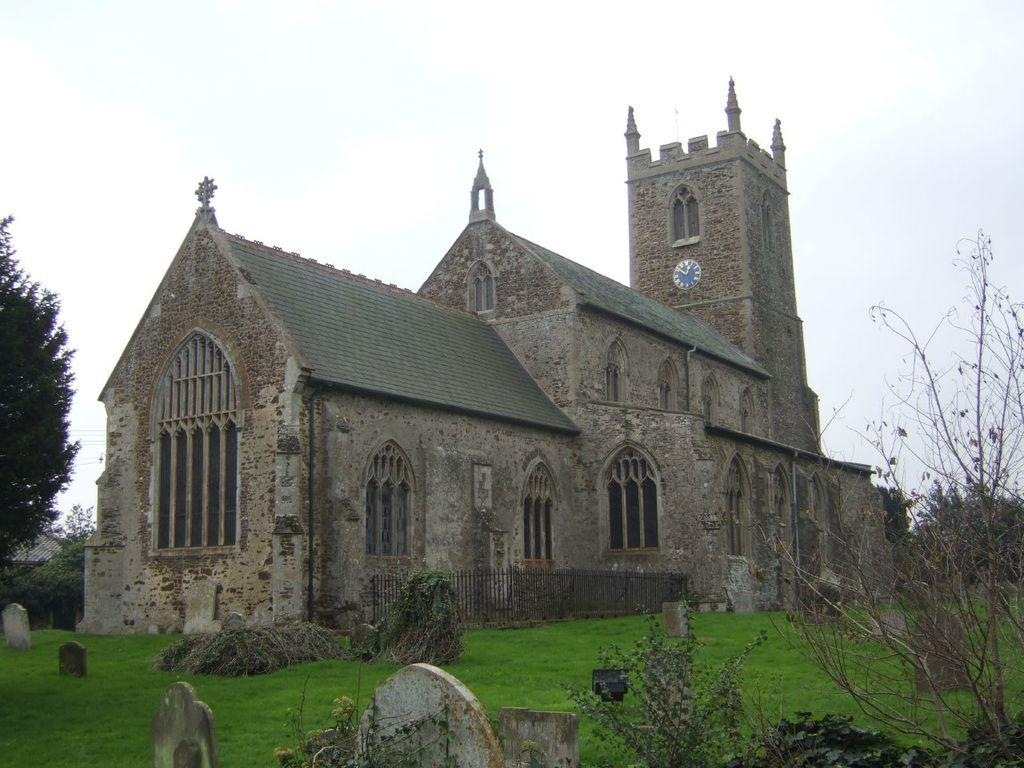What type of vegetation is present in the image? There is grass in the image. What type of structure can be seen in the image? There is a building in the image. What other natural elements are present in the image? There are trees in the image. What type of material is visible in the image? There are stones visible in the image. How many kittens are playing with the stones in the image? There are no kittens present in the image; it only features grass, a building, trees, and stones. What is the best route to take to reach the building in the image? The image does not provide enough information to determine the best route to reach the building. 